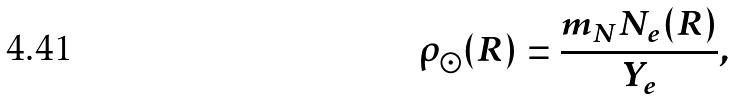Convert formula to latex. <formula><loc_0><loc_0><loc_500><loc_500>\rho _ { \odot } ( R ) = \frac { m _ { N } N _ { e } ( R ) } { Y _ { e } } ,</formula> 